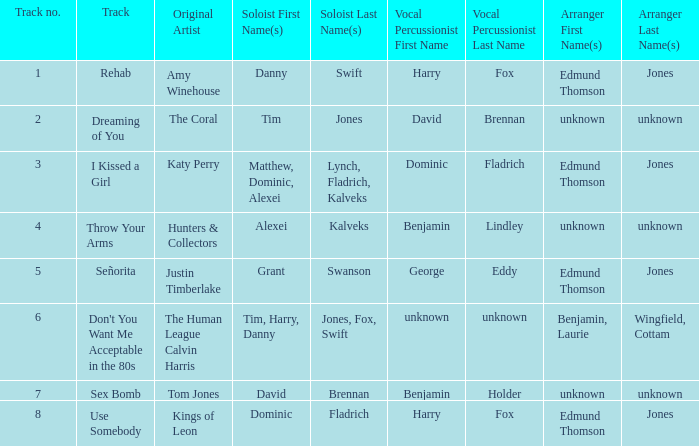Who is the percussionist for The Coral? David Brennan. 